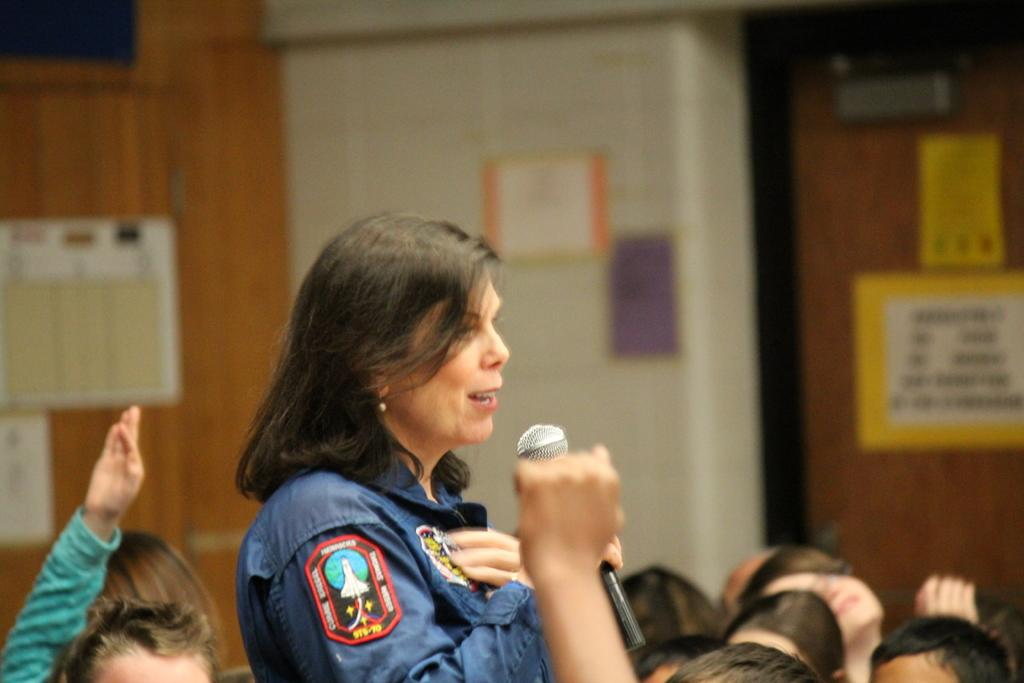Who is the main subject in the foreground of the image? There is a woman in the foreground of the image. What is the woman holding in the image? The woman is holding a microphone. Can you describe the background of the image? The background of the image is blurry. What type of magic trick is the woman performing with the microphone in the image? There is no indication of a magic trick being performed in the image; the woman is simply holding a microphone. What company does the woman represent in the image? There is no information about a company in the image. 